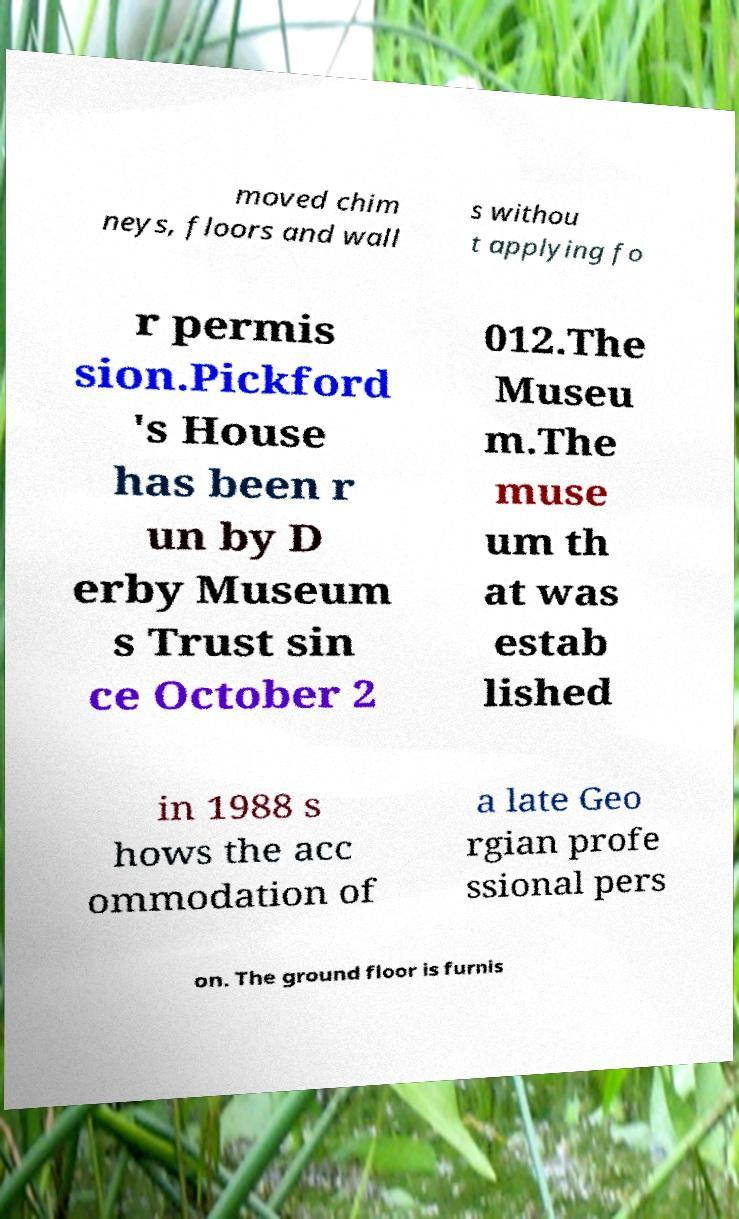Can you accurately transcribe the text from the provided image for me? moved chim neys, floors and wall s withou t applying fo r permis sion.Pickford 's House has been r un by D erby Museum s Trust sin ce October 2 012.The Museu m.The muse um th at was estab lished in 1988 s hows the acc ommodation of a late Geo rgian profe ssional pers on. The ground floor is furnis 